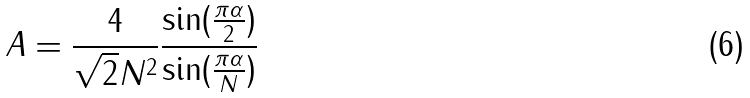<formula> <loc_0><loc_0><loc_500><loc_500>A = \frac { 4 } { \sqrt { 2 } N ^ { 2 } } \frac { \sin ( \frac { \pi \alpha } { 2 } ) } { \sin ( \frac { \pi \alpha } { N } ) }</formula> 